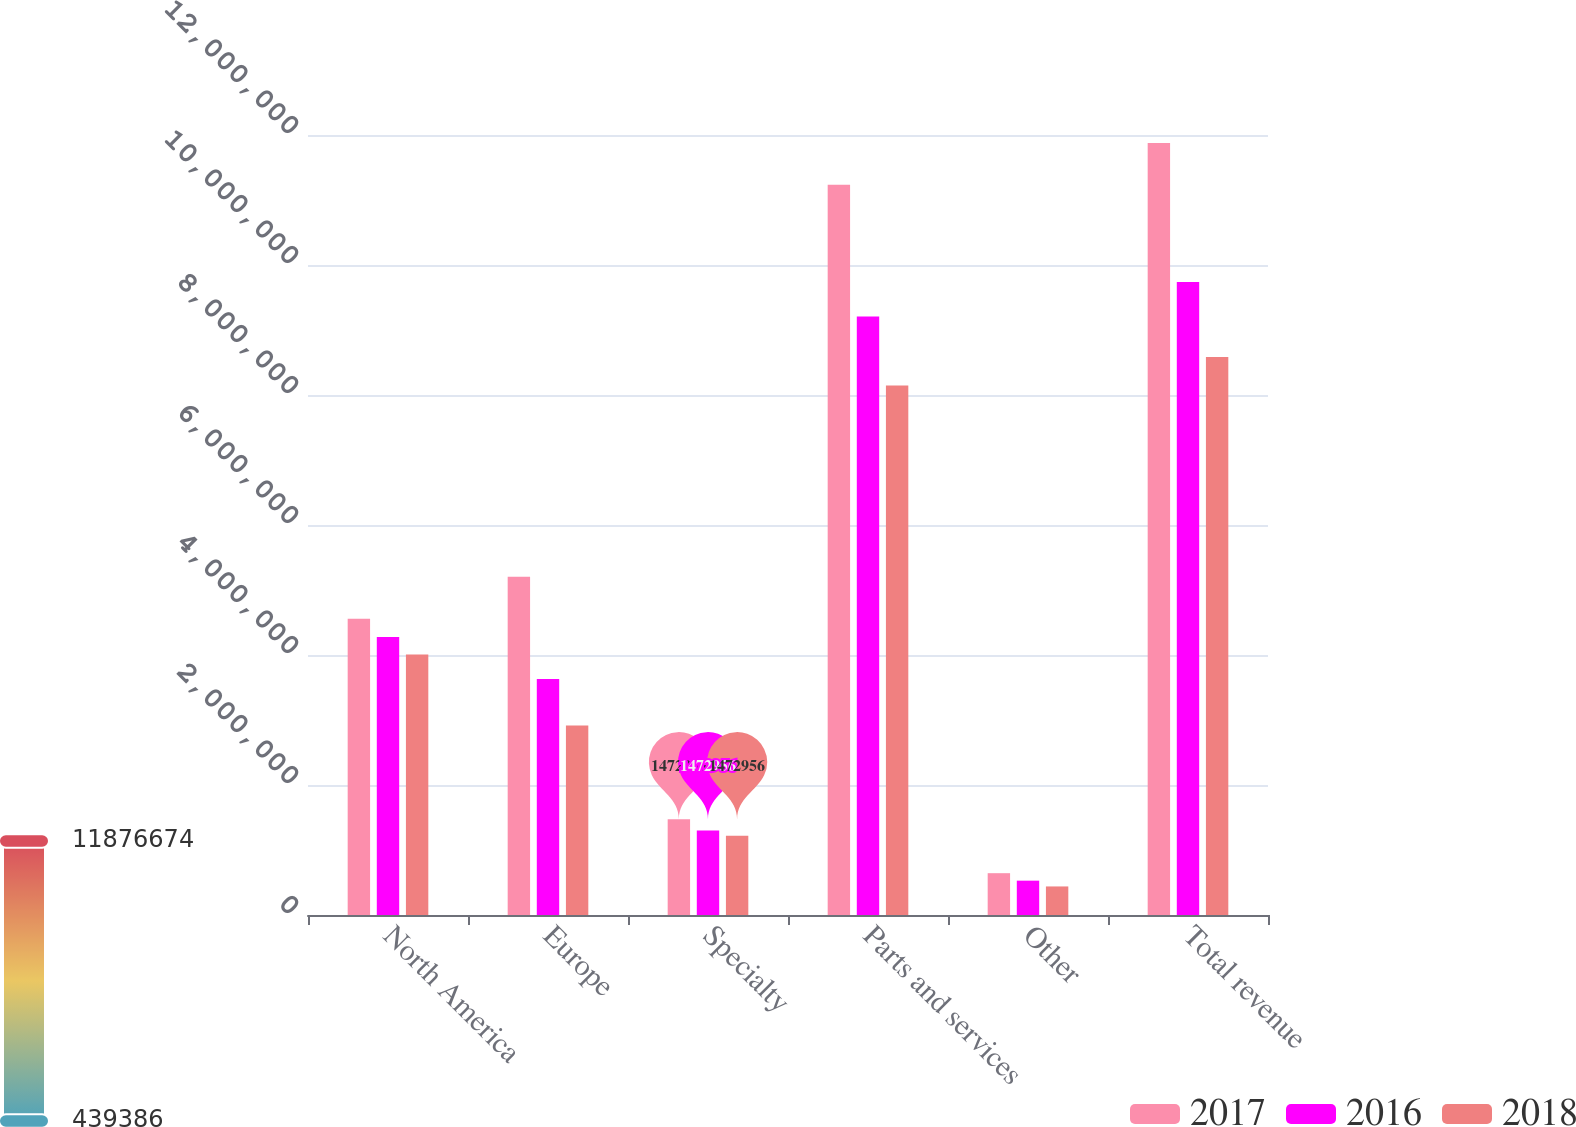Convert chart. <chart><loc_0><loc_0><loc_500><loc_500><stacked_bar_chart><ecel><fcel>North America<fcel>Europe<fcel>Specialty<fcel>Parts and services<fcel>Other<fcel>Total revenue<nl><fcel>2017<fcel>4.55822e+06<fcel>5.20223e+06<fcel>1.47296e+06<fcel>1.12334e+07<fcel>643267<fcel>1.18767e+07<nl><fcel>2016<fcel>4.27853e+06<fcel>3.62891e+06<fcel>1.3012e+06<fcel>9.20863e+06<fcel>528275<fcel>9.73691e+06<nl><fcel>2018<fcel>4.00913e+06<fcel>2.91584e+06<fcel>1.21968e+06<fcel>8.14464e+06<fcel>439386<fcel>8.58403e+06<nl></chart> 